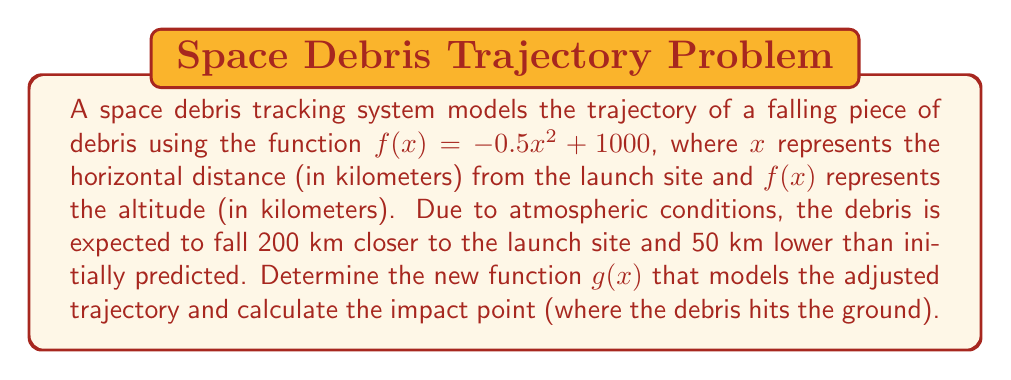Show me your answer to this math problem. To solve this problem, we need to apply function transformations and then find the roots of the resulting function.

1. First, let's apply the transformations to $f(x)$ to get $g(x)$:
   - Shift 200 km closer to the launch site: Replace $x$ with $(x + 200)$
   - Shift 50 km lower: Subtract 50 from the function

   $g(x) = f(x + 200) - 50$

2. Substituting the original function:
   $g(x) = -0.5(x + 200)^2 + 1000 - 50$

3. Simplify:
   $g(x) = -0.5(x^2 + 400x + 40000) + 950$
   $g(x) = -0.5x^2 - 200x - 20000 + 950$
   $g(x) = -0.5x^2 - 200x - 19050$

4. To find the impact point, we need to solve $g(x) = 0$:
   $-0.5x^2 - 200x - 19050 = 0$

5. This is a quadratic equation. Let's solve it using the quadratic formula:
   $x = \frac{-b \pm \sqrt{b^2 - 4ac}}{2a}$

   Where $a = -0.5$, $b = -200$, and $c = -19050$

6. Substituting these values:
   $x = \frac{200 \pm \sqrt{(-200)^2 - 4(-0.5)(-19050)}}{2(-0.5)}$
   $x = \frac{200 \pm \sqrt{40000 - 38100}}{-1}$
   $x = \frac{200 \pm \sqrt{1900}}{-1}$
   $x = \frac{200 \pm 43.59}{-1}$

7. This gives us two solutions:
   $x_1 = -243.59$ km
   $x_2 = -156.41$ km

8. Since we're measuring distance from the launch site, and negative values don't make physical sense in this context, we take the absolute value of the larger solution.

Therefore, the impact point is approximately 156.41 km from the launch site.
Answer: The new function modeling the adjusted trajectory is $g(x) = -0.5x^2 - 200x - 19050$, and the impact point is approximately 156.41 km from the launch site. 